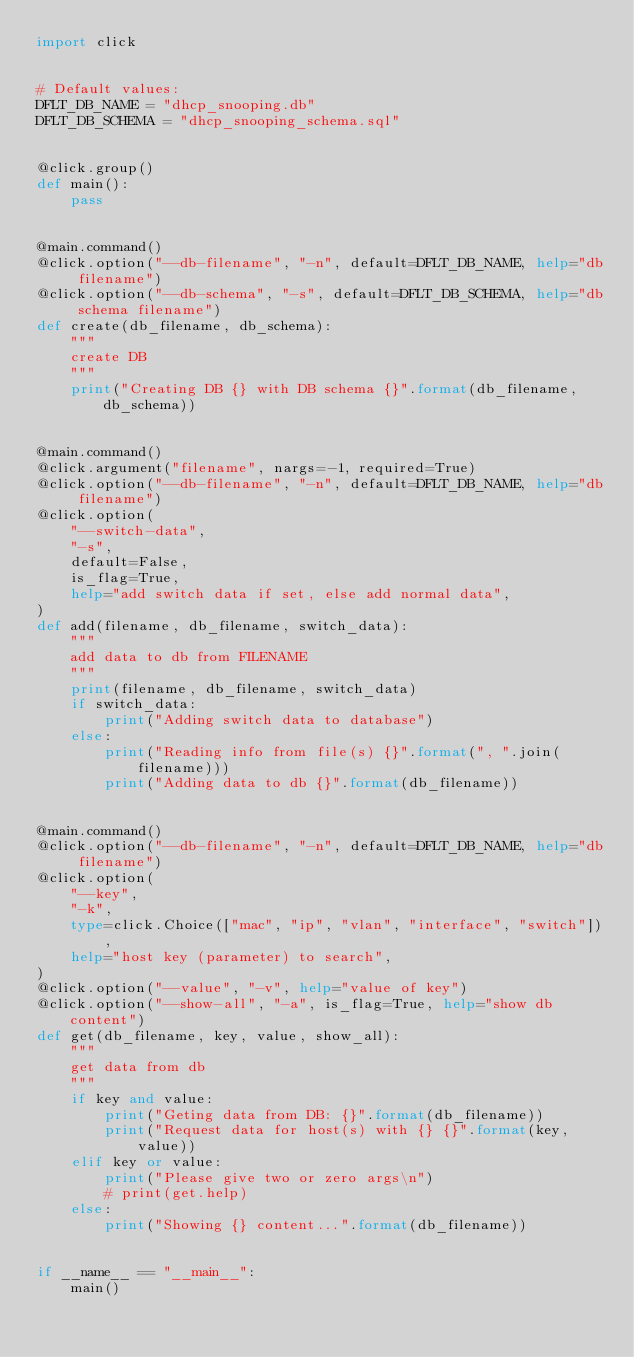<code> <loc_0><loc_0><loc_500><loc_500><_Python_>import click


# Default values:
DFLT_DB_NAME = "dhcp_snooping.db"
DFLT_DB_SCHEMA = "dhcp_snooping_schema.sql"


@click.group()
def main():
    pass


@main.command()
@click.option("--db-filename", "-n", default=DFLT_DB_NAME, help="db filename")
@click.option("--db-schema", "-s", default=DFLT_DB_SCHEMA, help="db schema filename")
def create(db_filename, db_schema):
    """
    create DB
    """
    print("Creating DB {} with DB schema {}".format(db_filename, db_schema))


@main.command()
@click.argument("filename", nargs=-1, required=True)
@click.option("--db-filename", "-n", default=DFLT_DB_NAME, help="db filename")
@click.option(
    "--switch-data",
    "-s",
    default=False,
    is_flag=True,
    help="add switch data if set, else add normal data",
)
def add(filename, db_filename, switch_data):
    """
    add data to db from FILENAME
    """
    print(filename, db_filename, switch_data)
    if switch_data:
        print("Adding switch data to database")
    else:
        print("Reading info from file(s) {}".format(", ".join(filename)))
        print("Adding data to db {}".format(db_filename))


@main.command()
@click.option("--db-filename", "-n", default=DFLT_DB_NAME, help="db filename")
@click.option(
    "--key",
    "-k",
    type=click.Choice(["mac", "ip", "vlan", "interface", "switch"]),
    help="host key (parameter) to search",
)
@click.option("--value", "-v", help="value of key")
@click.option("--show-all", "-a", is_flag=True, help="show db content")
def get(db_filename, key, value, show_all):
    """
    get data from db
    """
    if key and value:
        print("Geting data from DB: {}".format(db_filename))
        print("Request data for host(s) with {} {}".format(key, value))
    elif key or value:
        print("Please give two or zero args\n")
        # print(get.help)
    else:
        print("Showing {} content...".format(db_filename))


if __name__ == "__main__":
    main()
</code> 